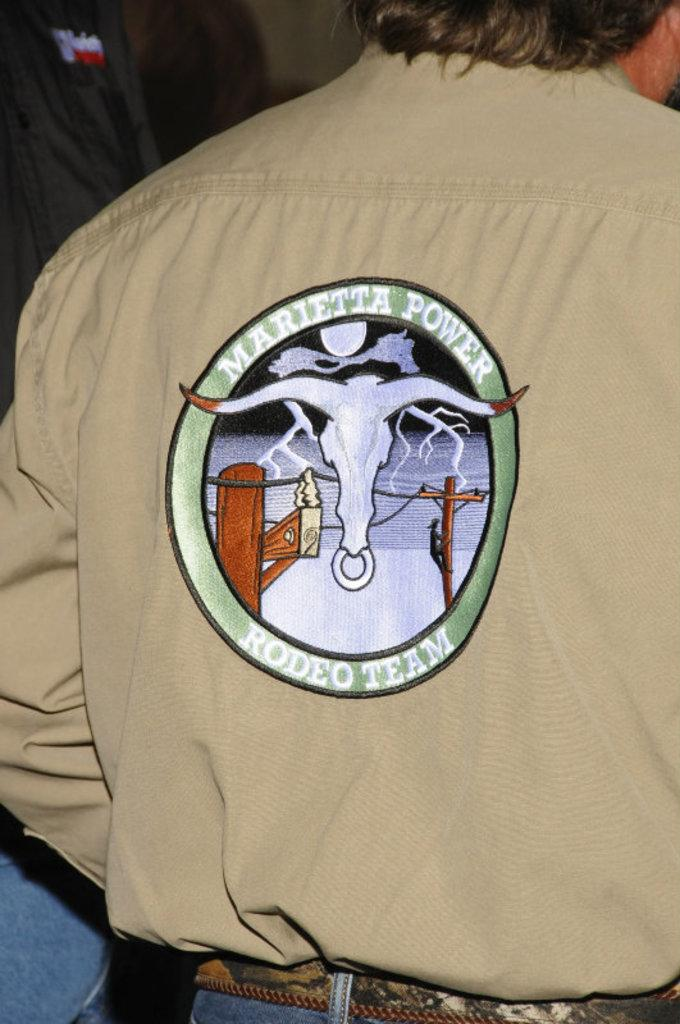Provide a one-sentence caption for the provided image. A person wears a tan shirt with "Marietta Power" on the back. 